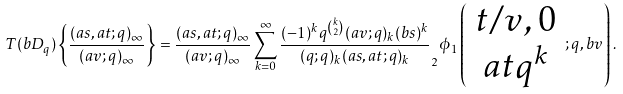Convert formula to latex. <formula><loc_0><loc_0><loc_500><loc_500>T ( b D _ { q } ) \left \{ \frac { ( a s , a t ; q ) _ { \infty } } { ( a v ; q ) _ { \infty } } \right \} = \frac { ( a s , a t ; q ) _ { \infty } } { ( a v ; q ) _ { \infty } } \sum _ { k = 0 } ^ { \infty } \frac { ( - 1 ) ^ { k } q ^ { k \choose 2 } ( a v ; q ) _ { k } ( b s ) ^ { k } } { ( q ; q ) _ { k } ( a s , a t ; q ) _ { k } } _ { 2 } \phi _ { 1 } \left ( \begin{array} { c } t / v , 0 \\ a t q ^ { k } \end{array} ; q , b v \right ) .</formula> 